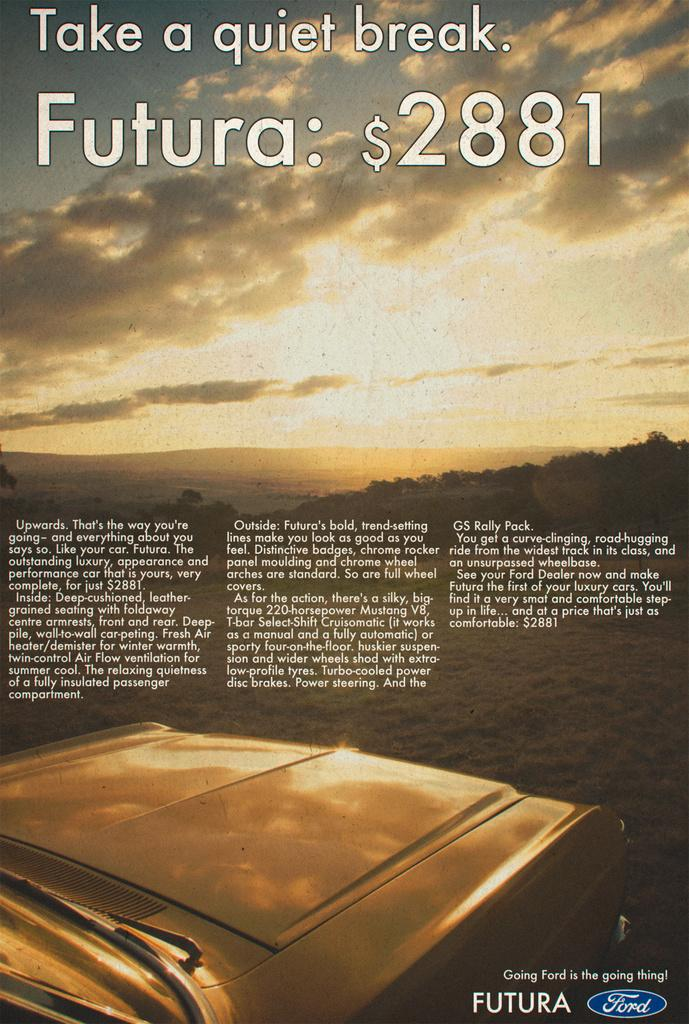<image>
Summarize the visual content of the image. A Ford ad encourages taking a quiet break. 